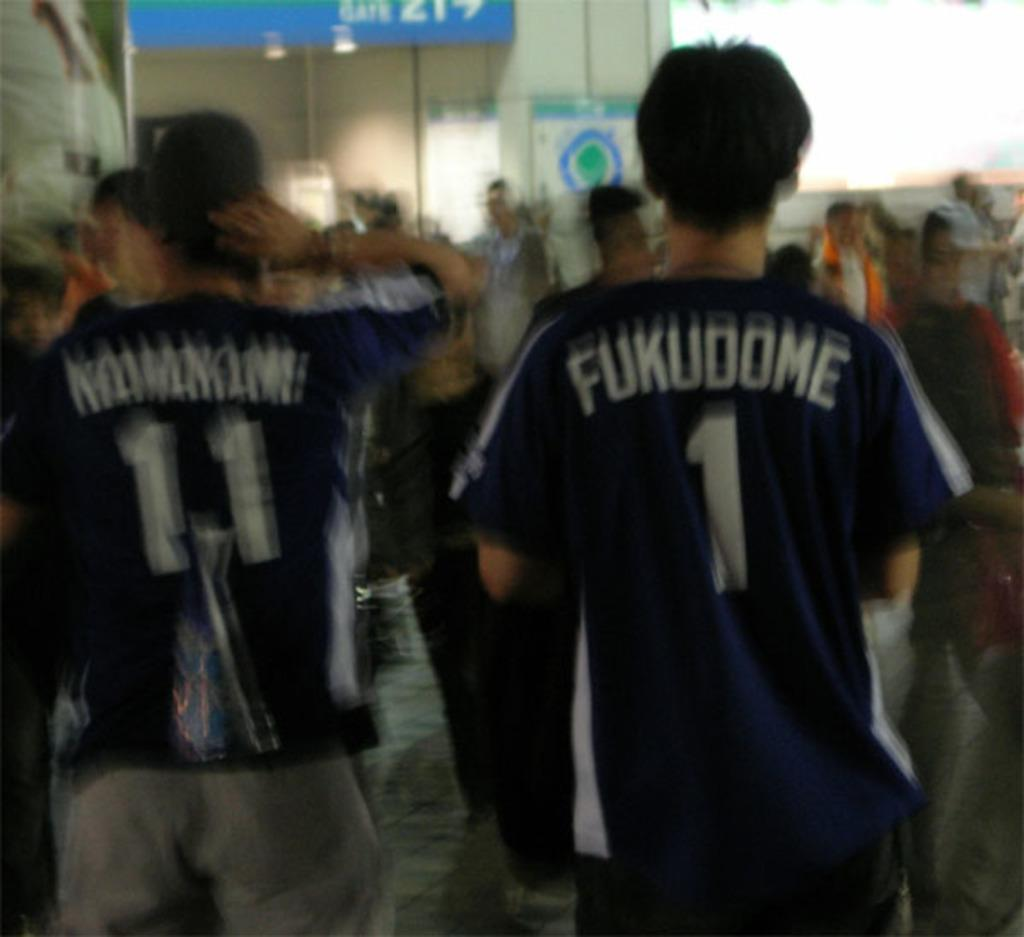Provide a one-sentence caption for the provided image. blurry people wear Fukudome 1 and 11 shirts. 